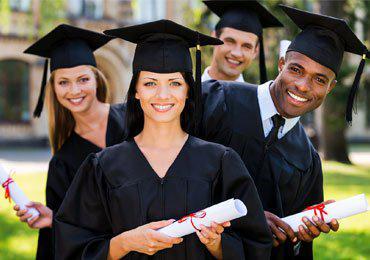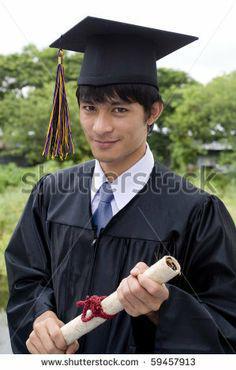The first image is the image on the left, the second image is the image on the right. Examine the images to the left and right. Is the description "A male is holding his diploma in the image on the right." accurate? Answer yes or no. Yes. The first image is the image on the left, the second image is the image on the right. Examine the images to the left and right. Is the description "The diplomas the people are holding have red ribbons around them." accurate? Answer yes or no. Yes. 